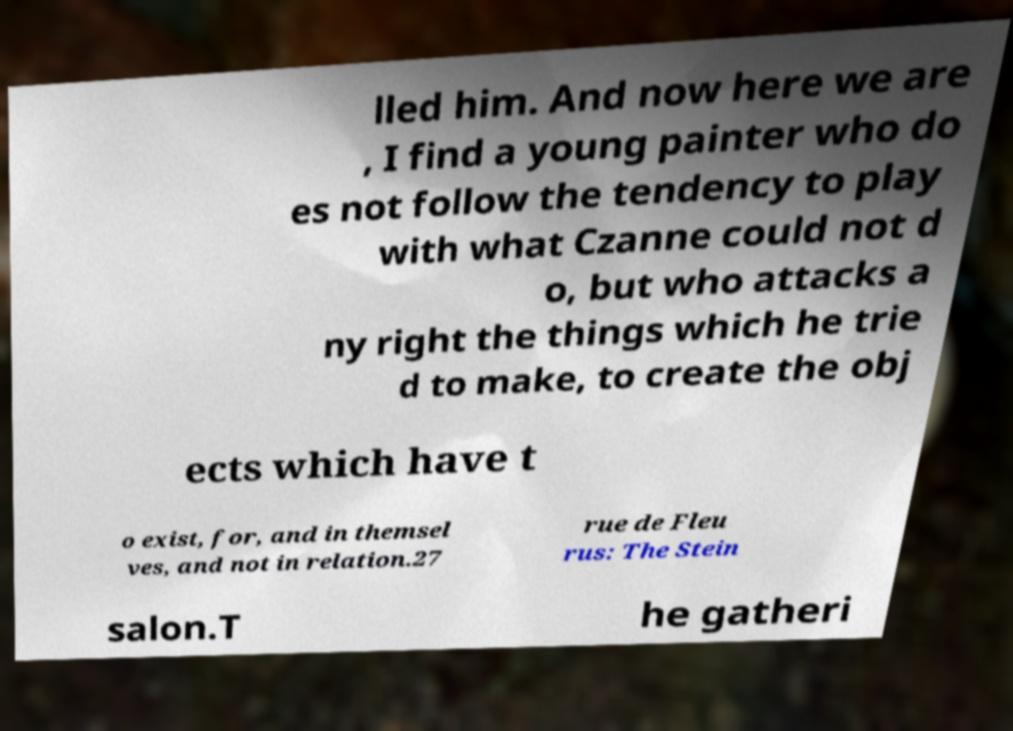I need the written content from this picture converted into text. Can you do that? lled him. And now here we are , I find a young painter who do es not follow the tendency to play with what Czanne could not d o, but who attacks a ny right the things which he trie d to make, to create the obj ects which have t o exist, for, and in themsel ves, and not in relation.27 rue de Fleu rus: The Stein salon.T he gatheri 